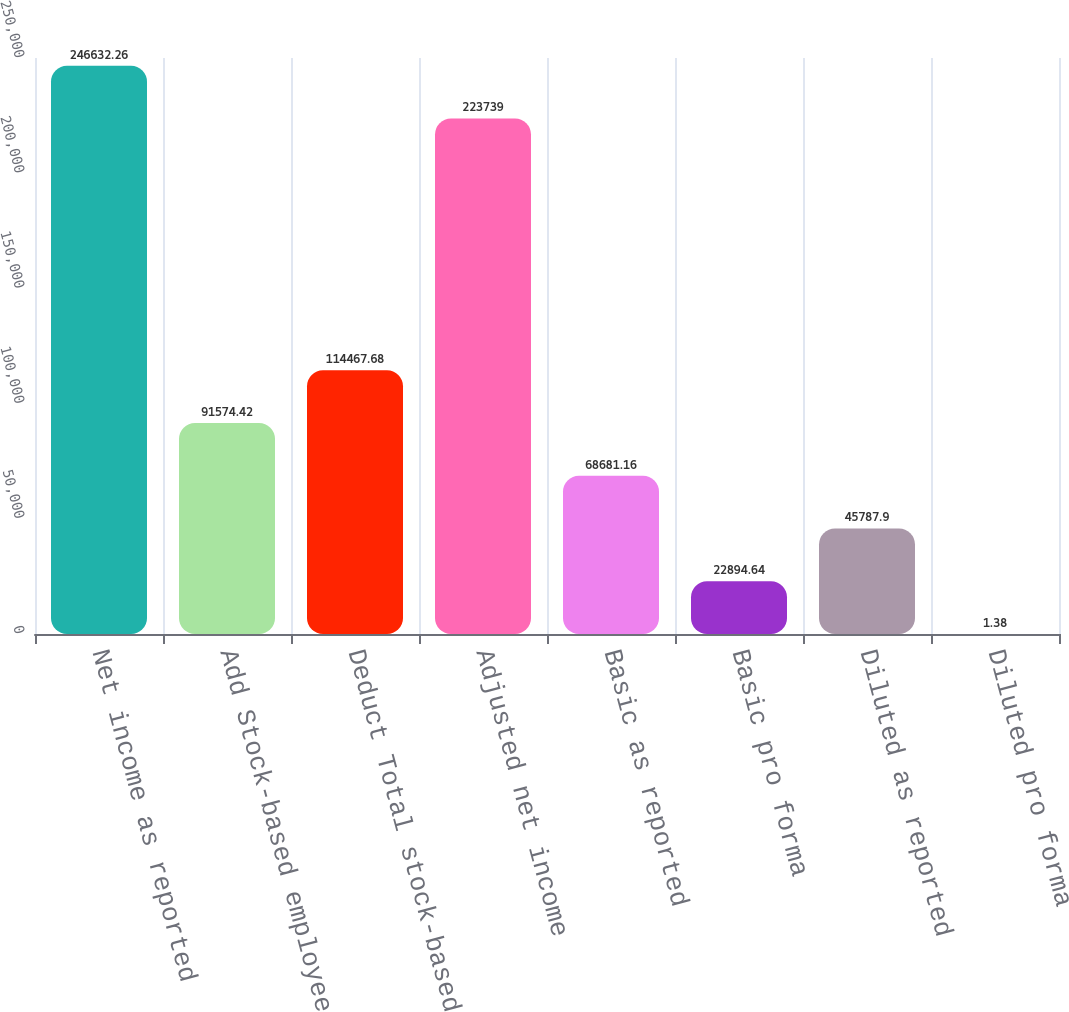Convert chart to OTSL. <chart><loc_0><loc_0><loc_500><loc_500><bar_chart><fcel>Net income as reported<fcel>Add Stock-based employee<fcel>Deduct Total stock-based<fcel>Adjusted net income<fcel>Basic as reported<fcel>Basic pro forma<fcel>Diluted as reported<fcel>Diluted pro forma<nl><fcel>246632<fcel>91574.4<fcel>114468<fcel>223739<fcel>68681.2<fcel>22894.6<fcel>45787.9<fcel>1.38<nl></chart> 